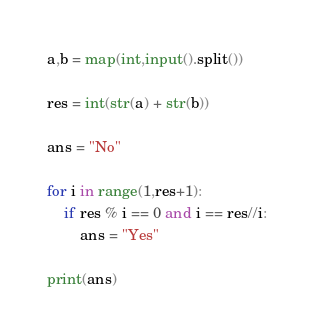<code> <loc_0><loc_0><loc_500><loc_500><_Python_>a,b = map(int,input().split())

res = int(str(a) + str(b))

ans = "No"

for i in range(1,res+1):
    if res % i == 0 and i == res//i:
        ans = "Yes"

print(ans)</code> 